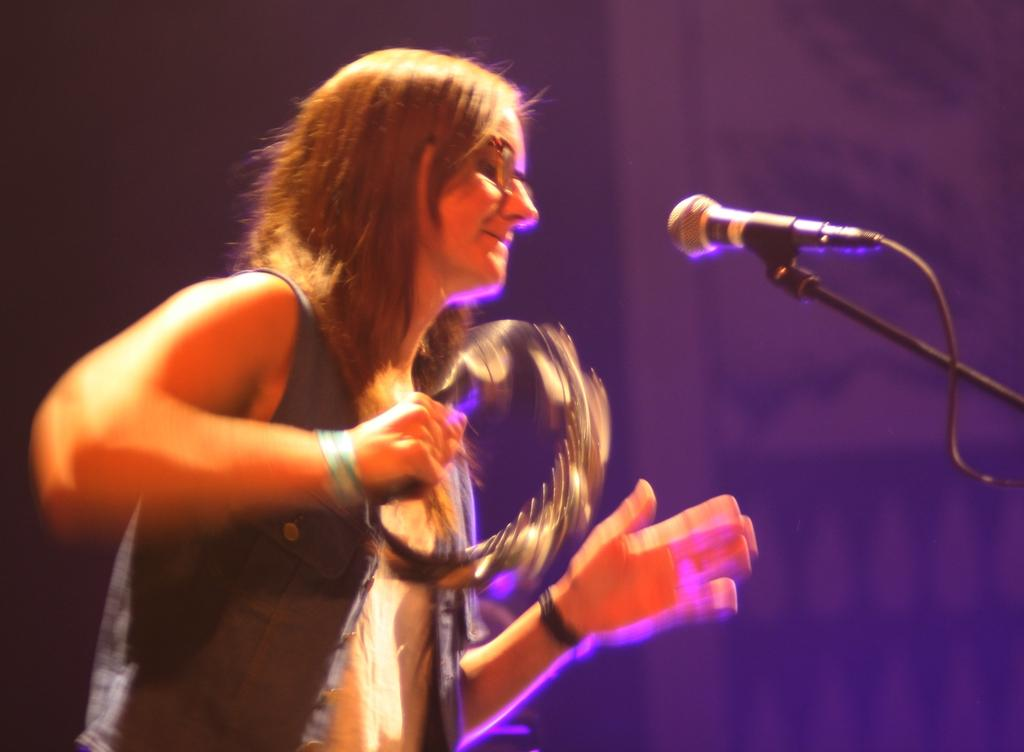Who is present in the image? There is a woman in the image. What is the woman holding in the image? The woman is holding an instrument. What can be seen near the woman in the image? There is a mic with a stand in the image. What type of pot is the woman using to teach dinosaurs in the image? There is no pot or dinosaurs present in the image, and the woman is not teaching anything. 